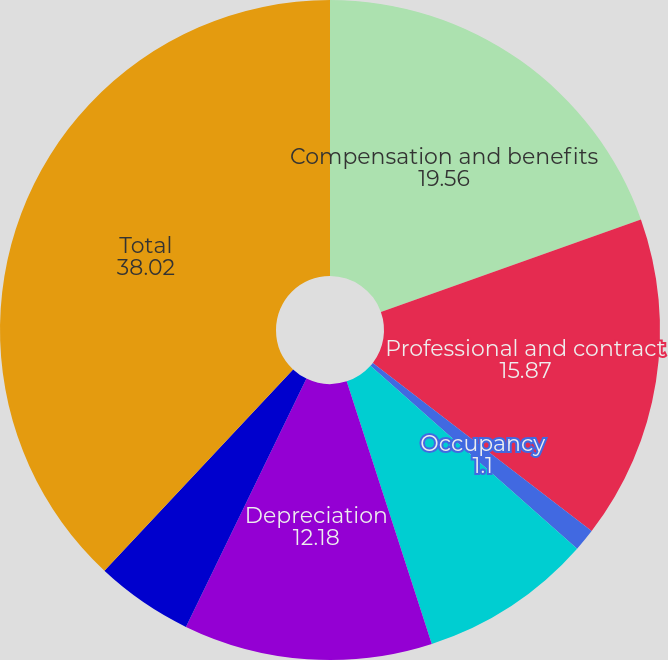Convert chart. <chart><loc_0><loc_0><loc_500><loc_500><pie_chart><fcel>Compensation and benefits<fcel>Professional and contract<fcel>Occupancy<fcel>Computer operations and data<fcel>Depreciation<fcel>General and administrative<fcel>Total<nl><fcel>19.56%<fcel>15.87%<fcel>1.1%<fcel>8.48%<fcel>12.18%<fcel>4.79%<fcel>38.02%<nl></chart> 